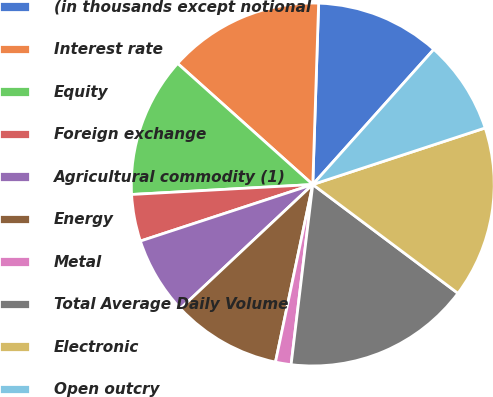<chart> <loc_0><loc_0><loc_500><loc_500><pie_chart><fcel>(in thousands except notional<fcel>Interest rate<fcel>Equity<fcel>Foreign exchange<fcel>Agricultural commodity (1)<fcel>Energy<fcel>Metal<fcel>Total Average Daily Volume<fcel>Electronic<fcel>Open outcry<nl><fcel>11.11%<fcel>13.89%<fcel>12.5%<fcel>4.17%<fcel>6.94%<fcel>9.72%<fcel>1.39%<fcel>16.67%<fcel>15.28%<fcel>8.33%<nl></chart> 